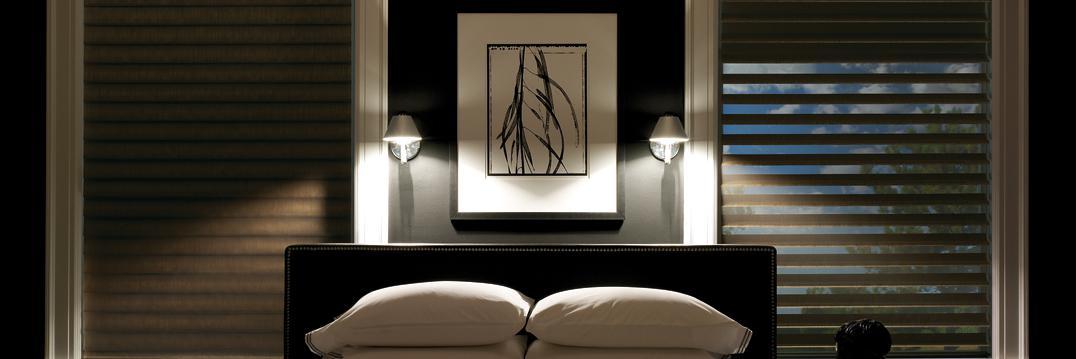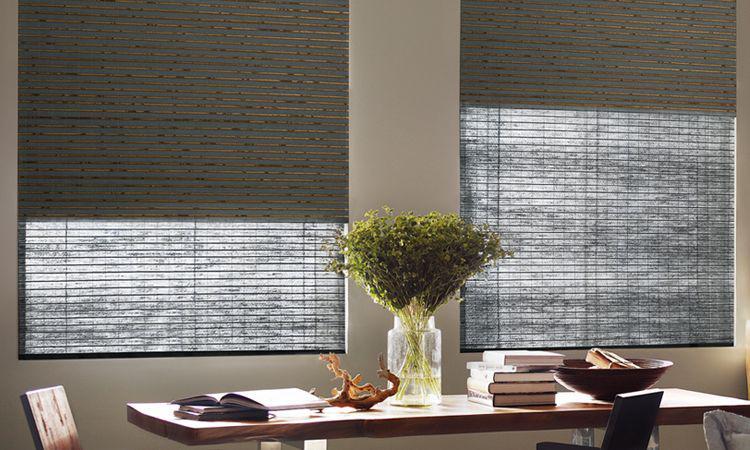The first image is the image on the left, the second image is the image on the right. For the images displayed, is the sentence "In at least one image there is a pant on a side table in front of blinds." factually correct? Answer yes or no. Yes. 